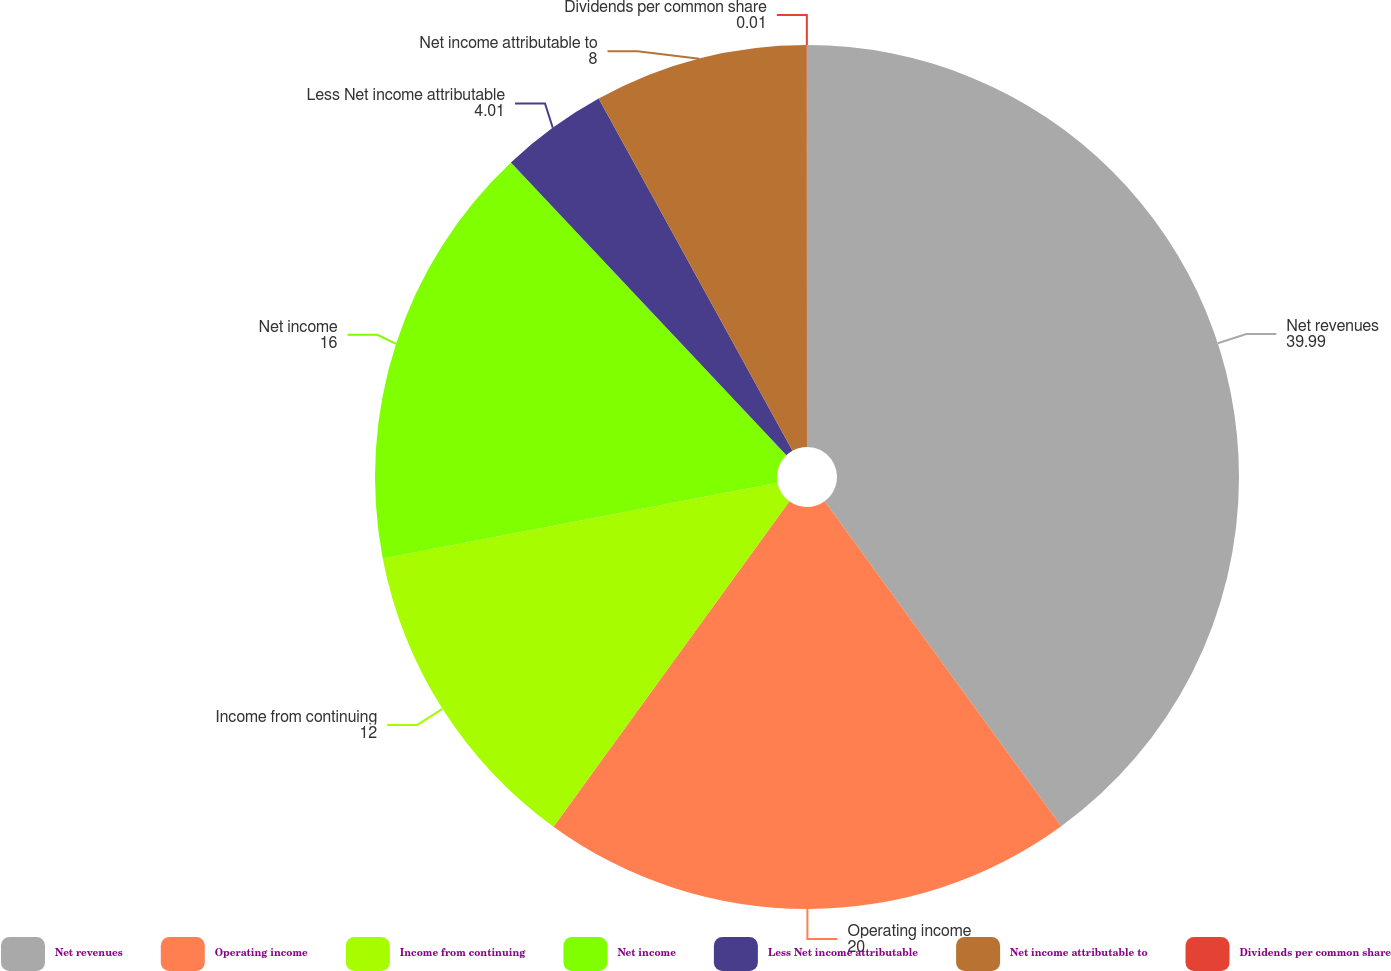<chart> <loc_0><loc_0><loc_500><loc_500><pie_chart><fcel>Net revenues<fcel>Operating income<fcel>Income from continuing<fcel>Net income<fcel>Less Net income attributable<fcel>Net income attributable to<fcel>Dividends per common share<nl><fcel>39.99%<fcel>20.0%<fcel>12.0%<fcel>16.0%<fcel>4.01%<fcel>8.0%<fcel>0.01%<nl></chart> 